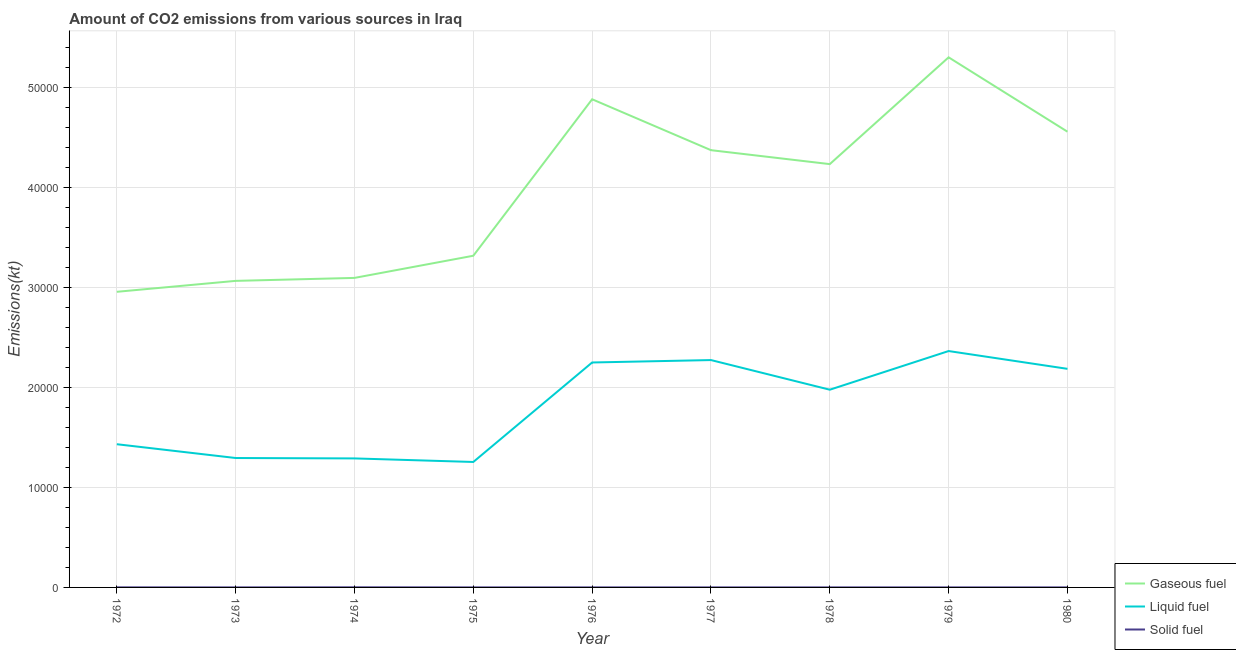What is the amount of co2 emissions from liquid fuel in 1972?
Offer a terse response. 1.43e+04. Across all years, what is the maximum amount of co2 emissions from solid fuel?
Make the answer very short. 11. Across all years, what is the minimum amount of co2 emissions from liquid fuel?
Make the answer very short. 1.25e+04. In which year was the amount of co2 emissions from gaseous fuel maximum?
Offer a terse response. 1979. What is the total amount of co2 emissions from solid fuel in the graph?
Provide a succinct answer. 44. What is the difference between the amount of co2 emissions from liquid fuel in 1973 and that in 1979?
Ensure brevity in your answer.  -1.07e+04. What is the difference between the amount of co2 emissions from gaseous fuel in 1975 and the amount of co2 emissions from solid fuel in 1972?
Offer a terse response. 3.31e+04. What is the average amount of co2 emissions from liquid fuel per year?
Offer a very short reply. 1.81e+04. In the year 1973, what is the difference between the amount of co2 emissions from gaseous fuel and amount of co2 emissions from solid fuel?
Provide a succinct answer. 3.06e+04. What is the ratio of the amount of co2 emissions from solid fuel in 1975 to that in 1980?
Your answer should be compact. 1. What is the difference between the highest and the second highest amount of co2 emissions from solid fuel?
Your answer should be very brief. 3.67. What is the difference between the highest and the lowest amount of co2 emissions from solid fuel?
Give a very brief answer. 7.33. In how many years, is the amount of co2 emissions from liquid fuel greater than the average amount of co2 emissions from liquid fuel taken over all years?
Provide a short and direct response. 5. Is it the case that in every year, the sum of the amount of co2 emissions from gaseous fuel and amount of co2 emissions from liquid fuel is greater than the amount of co2 emissions from solid fuel?
Your response must be concise. Yes. Is the amount of co2 emissions from gaseous fuel strictly greater than the amount of co2 emissions from liquid fuel over the years?
Your response must be concise. Yes. How many lines are there?
Ensure brevity in your answer.  3. How many years are there in the graph?
Provide a succinct answer. 9. Does the graph contain grids?
Provide a short and direct response. Yes. How are the legend labels stacked?
Keep it short and to the point. Vertical. What is the title of the graph?
Your answer should be compact. Amount of CO2 emissions from various sources in Iraq. What is the label or title of the Y-axis?
Keep it short and to the point. Emissions(kt). What is the Emissions(kt) of Gaseous fuel in 1972?
Give a very brief answer. 2.96e+04. What is the Emissions(kt) of Liquid fuel in 1972?
Provide a short and direct response. 1.43e+04. What is the Emissions(kt) in Solid fuel in 1972?
Provide a succinct answer. 7.33. What is the Emissions(kt) of Gaseous fuel in 1973?
Provide a succinct answer. 3.06e+04. What is the Emissions(kt) in Liquid fuel in 1973?
Keep it short and to the point. 1.29e+04. What is the Emissions(kt) in Solid fuel in 1973?
Your answer should be compact. 3.67. What is the Emissions(kt) in Gaseous fuel in 1974?
Provide a short and direct response. 3.09e+04. What is the Emissions(kt) of Liquid fuel in 1974?
Your response must be concise. 1.29e+04. What is the Emissions(kt) of Solid fuel in 1974?
Offer a very short reply. 11. What is the Emissions(kt) in Gaseous fuel in 1975?
Provide a short and direct response. 3.32e+04. What is the Emissions(kt) in Liquid fuel in 1975?
Offer a very short reply. 1.25e+04. What is the Emissions(kt) of Solid fuel in 1975?
Provide a short and direct response. 3.67. What is the Emissions(kt) in Gaseous fuel in 1976?
Provide a succinct answer. 4.88e+04. What is the Emissions(kt) of Liquid fuel in 1976?
Provide a succinct answer. 2.25e+04. What is the Emissions(kt) in Solid fuel in 1976?
Keep it short and to the point. 3.67. What is the Emissions(kt) of Gaseous fuel in 1977?
Ensure brevity in your answer.  4.37e+04. What is the Emissions(kt) of Liquid fuel in 1977?
Make the answer very short. 2.27e+04. What is the Emissions(kt) in Solid fuel in 1977?
Offer a very short reply. 3.67. What is the Emissions(kt) of Gaseous fuel in 1978?
Your answer should be compact. 4.23e+04. What is the Emissions(kt) of Liquid fuel in 1978?
Ensure brevity in your answer.  1.98e+04. What is the Emissions(kt) of Solid fuel in 1978?
Provide a short and direct response. 3.67. What is the Emissions(kt) in Gaseous fuel in 1979?
Offer a terse response. 5.30e+04. What is the Emissions(kt) of Liquid fuel in 1979?
Offer a very short reply. 2.36e+04. What is the Emissions(kt) of Solid fuel in 1979?
Make the answer very short. 3.67. What is the Emissions(kt) of Gaseous fuel in 1980?
Your answer should be very brief. 4.56e+04. What is the Emissions(kt) of Liquid fuel in 1980?
Offer a terse response. 2.19e+04. What is the Emissions(kt) of Solid fuel in 1980?
Your answer should be compact. 3.67. Across all years, what is the maximum Emissions(kt) in Gaseous fuel?
Offer a terse response. 5.30e+04. Across all years, what is the maximum Emissions(kt) of Liquid fuel?
Keep it short and to the point. 2.36e+04. Across all years, what is the maximum Emissions(kt) in Solid fuel?
Provide a succinct answer. 11. Across all years, what is the minimum Emissions(kt) of Gaseous fuel?
Offer a terse response. 2.96e+04. Across all years, what is the minimum Emissions(kt) of Liquid fuel?
Your answer should be very brief. 1.25e+04. Across all years, what is the minimum Emissions(kt) in Solid fuel?
Ensure brevity in your answer.  3.67. What is the total Emissions(kt) in Gaseous fuel in the graph?
Your answer should be very brief. 3.58e+05. What is the total Emissions(kt) of Liquid fuel in the graph?
Your response must be concise. 1.63e+05. What is the total Emissions(kt) in Solid fuel in the graph?
Give a very brief answer. 44. What is the difference between the Emissions(kt) of Gaseous fuel in 1972 and that in 1973?
Your answer should be very brief. -1092.77. What is the difference between the Emissions(kt) in Liquid fuel in 1972 and that in 1973?
Your answer should be very brief. 1378.79. What is the difference between the Emissions(kt) in Solid fuel in 1972 and that in 1973?
Your response must be concise. 3.67. What is the difference between the Emissions(kt) of Gaseous fuel in 1972 and that in 1974?
Offer a very short reply. -1389.79. What is the difference between the Emissions(kt) of Liquid fuel in 1972 and that in 1974?
Your response must be concise. 1419.13. What is the difference between the Emissions(kt) of Solid fuel in 1972 and that in 1974?
Your answer should be compact. -3.67. What is the difference between the Emissions(kt) in Gaseous fuel in 1972 and that in 1975?
Ensure brevity in your answer.  -3604.66. What is the difference between the Emissions(kt) in Liquid fuel in 1972 and that in 1975?
Keep it short and to the point. 1774.83. What is the difference between the Emissions(kt) of Solid fuel in 1972 and that in 1975?
Your answer should be compact. 3.67. What is the difference between the Emissions(kt) of Gaseous fuel in 1972 and that in 1976?
Ensure brevity in your answer.  -1.92e+04. What is the difference between the Emissions(kt) in Liquid fuel in 1972 and that in 1976?
Your response must be concise. -8170.08. What is the difference between the Emissions(kt) in Solid fuel in 1972 and that in 1976?
Your answer should be very brief. 3.67. What is the difference between the Emissions(kt) of Gaseous fuel in 1972 and that in 1977?
Give a very brief answer. -1.42e+04. What is the difference between the Emissions(kt) of Liquid fuel in 1972 and that in 1977?
Provide a succinct answer. -8412.1. What is the difference between the Emissions(kt) in Solid fuel in 1972 and that in 1977?
Make the answer very short. 3.67. What is the difference between the Emissions(kt) of Gaseous fuel in 1972 and that in 1978?
Keep it short and to the point. -1.28e+04. What is the difference between the Emissions(kt) in Liquid fuel in 1972 and that in 1978?
Provide a short and direct response. -5449.16. What is the difference between the Emissions(kt) in Solid fuel in 1972 and that in 1978?
Ensure brevity in your answer.  3.67. What is the difference between the Emissions(kt) in Gaseous fuel in 1972 and that in 1979?
Your answer should be compact. -2.34e+04. What is the difference between the Emissions(kt) in Liquid fuel in 1972 and that in 1979?
Provide a succinct answer. -9314.18. What is the difference between the Emissions(kt) in Solid fuel in 1972 and that in 1979?
Keep it short and to the point. 3.67. What is the difference between the Emissions(kt) of Gaseous fuel in 1972 and that in 1980?
Provide a short and direct response. -1.60e+04. What is the difference between the Emissions(kt) in Liquid fuel in 1972 and that in 1980?
Keep it short and to the point. -7535.69. What is the difference between the Emissions(kt) in Solid fuel in 1972 and that in 1980?
Provide a succinct answer. 3.67. What is the difference between the Emissions(kt) of Gaseous fuel in 1973 and that in 1974?
Keep it short and to the point. -297.03. What is the difference between the Emissions(kt) in Liquid fuel in 1973 and that in 1974?
Your answer should be compact. 40.34. What is the difference between the Emissions(kt) of Solid fuel in 1973 and that in 1974?
Your answer should be compact. -7.33. What is the difference between the Emissions(kt) in Gaseous fuel in 1973 and that in 1975?
Your answer should be very brief. -2511.89. What is the difference between the Emissions(kt) in Liquid fuel in 1973 and that in 1975?
Offer a very short reply. 396.04. What is the difference between the Emissions(kt) in Solid fuel in 1973 and that in 1975?
Make the answer very short. 0. What is the difference between the Emissions(kt) in Gaseous fuel in 1973 and that in 1976?
Provide a succinct answer. -1.82e+04. What is the difference between the Emissions(kt) in Liquid fuel in 1973 and that in 1976?
Provide a succinct answer. -9548.87. What is the difference between the Emissions(kt) in Solid fuel in 1973 and that in 1976?
Ensure brevity in your answer.  0. What is the difference between the Emissions(kt) in Gaseous fuel in 1973 and that in 1977?
Offer a terse response. -1.31e+04. What is the difference between the Emissions(kt) in Liquid fuel in 1973 and that in 1977?
Offer a terse response. -9790.89. What is the difference between the Emissions(kt) in Solid fuel in 1973 and that in 1977?
Your answer should be very brief. 0. What is the difference between the Emissions(kt) of Gaseous fuel in 1973 and that in 1978?
Offer a terse response. -1.17e+04. What is the difference between the Emissions(kt) in Liquid fuel in 1973 and that in 1978?
Provide a succinct answer. -6827.95. What is the difference between the Emissions(kt) in Solid fuel in 1973 and that in 1978?
Your answer should be compact. 0. What is the difference between the Emissions(kt) of Gaseous fuel in 1973 and that in 1979?
Keep it short and to the point. -2.23e+04. What is the difference between the Emissions(kt) of Liquid fuel in 1973 and that in 1979?
Make the answer very short. -1.07e+04. What is the difference between the Emissions(kt) in Gaseous fuel in 1973 and that in 1980?
Offer a very short reply. -1.49e+04. What is the difference between the Emissions(kt) of Liquid fuel in 1973 and that in 1980?
Your answer should be compact. -8914.48. What is the difference between the Emissions(kt) in Gaseous fuel in 1974 and that in 1975?
Keep it short and to the point. -2214.87. What is the difference between the Emissions(kt) in Liquid fuel in 1974 and that in 1975?
Your answer should be very brief. 355.7. What is the difference between the Emissions(kt) in Solid fuel in 1974 and that in 1975?
Make the answer very short. 7.33. What is the difference between the Emissions(kt) of Gaseous fuel in 1974 and that in 1976?
Keep it short and to the point. -1.79e+04. What is the difference between the Emissions(kt) of Liquid fuel in 1974 and that in 1976?
Keep it short and to the point. -9589.2. What is the difference between the Emissions(kt) in Solid fuel in 1974 and that in 1976?
Your answer should be very brief. 7.33. What is the difference between the Emissions(kt) of Gaseous fuel in 1974 and that in 1977?
Keep it short and to the point. -1.28e+04. What is the difference between the Emissions(kt) in Liquid fuel in 1974 and that in 1977?
Ensure brevity in your answer.  -9831.23. What is the difference between the Emissions(kt) in Solid fuel in 1974 and that in 1977?
Keep it short and to the point. 7.33. What is the difference between the Emissions(kt) in Gaseous fuel in 1974 and that in 1978?
Keep it short and to the point. -1.14e+04. What is the difference between the Emissions(kt) of Liquid fuel in 1974 and that in 1978?
Your answer should be compact. -6868.29. What is the difference between the Emissions(kt) in Solid fuel in 1974 and that in 1978?
Offer a very short reply. 7.33. What is the difference between the Emissions(kt) of Gaseous fuel in 1974 and that in 1979?
Offer a very short reply. -2.20e+04. What is the difference between the Emissions(kt) of Liquid fuel in 1974 and that in 1979?
Make the answer very short. -1.07e+04. What is the difference between the Emissions(kt) in Solid fuel in 1974 and that in 1979?
Make the answer very short. 7.33. What is the difference between the Emissions(kt) in Gaseous fuel in 1974 and that in 1980?
Your answer should be very brief. -1.46e+04. What is the difference between the Emissions(kt) in Liquid fuel in 1974 and that in 1980?
Give a very brief answer. -8954.81. What is the difference between the Emissions(kt) in Solid fuel in 1974 and that in 1980?
Keep it short and to the point. 7.33. What is the difference between the Emissions(kt) of Gaseous fuel in 1975 and that in 1976?
Your answer should be very brief. -1.56e+04. What is the difference between the Emissions(kt) of Liquid fuel in 1975 and that in 1976?
Provide a succinct answer. -9944.9. What is the difference between the Emissions(kt) in Solid fuel in 1975 and that in 1976?
Your response must be concise. 0. What is the difference between the Emissions(kt) in Gaseous fuel in 1975 and that in 1977?
Ensure brevity in your answer.  -1.06e+04. What is the difference between the Emissions(kt) in Liquid fuel in 1975 and that in 1977?
Provide a succinct answer. -1.02e+04. What is the difference between the Emissions(kt) of Solid fuel in 1975 and that in 1977?
Provide a short and direct response. 0. What is the difference between the Emissions(kt) in Gaseous fuel in 1975 and that in 1978?
Provide a succinct answer. -9160.17. What is the difference between the Emissions(kt) of Liquid fuel in 1975 and that in 1978?
Provide a short and direct response. -7223.99. What is the difference between the Emissions(kt) in Gaseous fuel in 1975 and that in 1979?
Your answer should be compact. -1.98e+04. What is the difference between the Emissions(kt) in Liquid fuel in 1975 and that in 1979?
Make the answer very short. -1.11e+04. What is the difference between the Emissions(kt) in Solid fuel in 1975 and that in 1979?
Provide a succinct answer. 0. What is the difference between the Emissions(kt) of Gaseous fuel in 1975 and that in 1980?
Keep it short and to the point. -1.24e+04. What is the difference between the Emissions(kt) of Liquid fuel in 1975 and that in 1980?
Give a very brief answer. -9310.51. What is the difference between the Emissions(kt) in Gaseous fuel in 1976 and that in 1977?
Offer a very short reply. 5089.8. What is the difference between the Emissions(kt) in Liquid fuel in 1976 and that in 1977?
Your answer should be very brief. -242.02. What is the difference between the Emissions(kt) in Solid fuel in 1976 and that in 1977?
Your answer should be very brief. 0. What is the difference between the Emissions(kt) in Gaseous fuel in 1976 and that in 1978?
Your response must be concise. 6483.26. What is the difference between the Emissions(kt) in Liquid fuel in 1976 and that in 1978?
Keep it short and to the point. 2720.91. What is the difference between the Emissions(kt) in Solid fuel in 1976 and that in 1978?
Provide a short and direct response. 0. What is the difference between the Emissions(kt) of Gaseous fuel in 1976 and that in 1979?
Your answer should be very brief. -4191.38. What is the difference between the Emissions(kt) in Liquid fuel in 1976 and that in 1979?
Ensure brevity in your answer.  -1144.1. What is the difference between the Emissions(kt) in Gaseous fuel in 1976 and that in 1980?
Give a very brief answer. 3241.63. What is the difference between the Emissions(kt) of Liquid fuel in 1976 and that in 1980?
Make the answer very short. 634.39. What is the difference between the Emissions(kt) of Gaseous fuel in 1977 and that in 1978?
Ensure brevity in your answer.  1393.46. What is the difference between the Emissions(kt) of Liquid fuel in 1977 and that in 1978?
Make the answer very short. 2962.94. What is the difference between the Emissions(kt) of Solid fuel in 1977 and that in 1978?
Give a very brief answer. 0. What is the difference between the Emissions(kt) in Gaseous fuel in 1977 and that in 1979?
Offer a terse response. -9281.18. What is the difference between the Emissions(kt) of Liquid fuel in 1977 and that in 1979?
Keep it short and to the point. -902.08. What is the difference between the Emissions(kt) in Solid fuel in 1977 and that in 1979?
Your answer should be very brief. 0. What is the difference between the Emissions(kt) in Gaseous fuel in 1977 and that in 1980?
Your answer should be very brief. -1848.17. What is the difference between the Emissions(kt) of Liquid fuel in 1977 and that in 1980?
Your answer should be compact. 876.41. What is the difference between the Emissions(kt) in Gaseous fuel in 1978 and that in 1979?
Provide a succinct answer. -1.07e+04. What is the difference between the Emissions(kt) of Liquid fuel in 1978 and that in 1979?
Your answer should be compact. -3865.02. What is the difference between the Emissions(kt) of Solid fuel in 1978 and that in 1979?
Offer a very short reply. 0. What is the difference between the Emissions(kt) in Gaseous fuel in 1978 and that in 1980?
Provide a succinct answer. -3241.63. What is the difference between the Emissions(kt) in Liquid fuel in 1978 and that in 1980?
Offer a terse response. -2086.52. What is the difference between the Emissions(kt) in Solid fuel in 1978 and that in 1980?
Offer a terse response. 0. What is the difference between the Emissions(kt) of Gaseous fuel in 1979 and that in 1980?
Ensure brevity in your answer.  7433.01. What is the difference between the Emissions(kt) in Liquid fuel in 1979 and that in 1980?
Your answer should be very brief. 1778.49. What is the difference between the Emissions(kt) in Gaseous fuel in 1972 and the Emissions(kt) in Liquid fuel in 1973?
Provide a succinct answer. 1.66e+04. What is the difference between the Emissions(kt) of Gaseous fuel in 1972 and the Emissions(kt) of Solid fuel in 1973?
Offer a very short reply. 2.95e+04. What is the difference between the Emissions(kt) in Liquid fuel in 1972 and the Emissions(kt) in Solid fuel in 1973?
Provide a short and direct response. 1.43e+04. What is the difference between the Emissions(kt) in Gaseous fuel in 1972 and the Emissions(kt) in Liquid fuel in 1974?
Provide a succinct answer. 1.67e+04. What is the difference between the Emissions(kt) of Gaseous fuel in 1972 and the Emissions(kt) of Solid fuel in 1974?
Make the answer very short. 2.95e+04. What is the difference between the Emissions(kt) in Liquid fuel in 1972 and the Emissions(kt) in Solid fuel in 1974?
Ensure brevity in your answer.  1.43e+04. What is the difference between the Emissions(kt) in Gaseous fuel in 1972 and the Emissions(kt) in Liquid fuel in 1975?
Your answer should be compact. 1.70e+04. What is the difference between the Emissions(kt) in Gaseous fuel in 1972 and the Emissions(kt) in Solid fuel in 1975?
Give a very brief answer. 2.95e+04. What is the difference between the Emissions(kt) in Liquid fuel in 1972 and the Emissions(kt) in Solid fuel in 1975?
Keep it short and to the point. 1.43e+04. What is the difference between the Emissions(kt) of Gaseous fuel in 1972 and the Emissions(kt) of Liquid fuel in 1976?
Offer a very short reply. 7066.31. What is the difference between the Emissions(kt) in Gaseous fuel in 1972 and the Emissions(kt) in Solid fuel in 1976?
Provide a short and direct response. 2.95e+04. What is the difference between the Emissions(kt) in Liquid fuel in 1972 and the Emissions(kt) in Solid fuel in 1976?
Provide a short and direct response. 1.43e+04. What is the difference between the Emissions(kt) in Gaseous fuel in 1972 and the Emissions(kt) in Liquid fuel in 1977?
Provide a short and direct response. 6824.29. What is the difference between the Emissions(kt) of Gaseous fuel in 1972 and the Emissions(kt) of Solid fuel in 1977?
Offer a very short reply. 2.95e+04. What is the difference between the Emissions(kt) in Liquid fuel in 1972 and the Emissions(kt) in Solid fuel in 1977?
Ensure brevity in your answer.  1.43e+04. What is the difference between the Emissions(kt) in Gaseous fuel in 1972 and the Emissions(kt) in Liquid fuel in 1978?
Make the answer very short. 9787.22. What is the difference between the Emissions(kt) in Gaseous fuel in 1972 and the Emissions(kt) in Solid fuel in 1978?
Your response must be concise. 2.95e+04. What is the difference between the Emissions(kt) of Liquid fuel in 1972 and the Emissions(kt) of Solid fuel in 1978?
Ensure brevity in your answer.  1.43e+04. What is the difference between the Emissions(kt) of Gaseous fuel in 1972 and the Emissions(kt) of Liquid fuel in 1979?
Keep it short and to the point. 5922.2. What is the difference between the Emissions(kt) of Gaseous fuel in 1972 and the Emissions(kt) of Solid fuel in 1979?
Provide a short and direct response. 2.95e+04. What is the difference between the Emissions(kt) of Liquid fuel in 1972 and the Emissions(kt) of Solid fuel in 1979?
Your answer should be compact. 1.43e+04. What is the difference between the Emissions(kt) in Gaseous fuel in 1972 and the Emissions(kt) in Liquid fuel in 1980?
Provide a short and direct response. 7700.7. What is the difference between the Emissions(kt) of Gaseous fuel in 1972 and the Emissions(kt) of Solid fuel in 1980?
Your response must be concise. 2.95e+04. What is the difference between the Emissions(kt) in Liquid fuel in 1972 and the Emissions(kt) in Solid fuel in 1980?
Provide a succinct answer. 1.43e+04. What is the difference between the Emissions(kt) of Gaseous fuel in 1973 and the Emissions(kt) of Liquid fuel in 1974?
Give a very brief answer. 1.77e+04. What is the difference between the Emissions(kt) of Gaseous fuel in 1973 and the Emissions(kt) of Solid fuel in 1974?
Keep it short and to the point. 3.06e+04. What is the difference between the Emissions(kt) of Liquid fuel in 1973 and the Emissions(kt) of Solid fuel in 1974?
Provide a short and direct response. 1.29e+04. What is the difference between the Emissions(kt) in Gaseous fuel in 1973 and the Emissions(kt) in Liquid fuel in 1975?
Keep it short and to the point. 1.81e+04. What is the difference between the Emissions(kt) of Gaseous fuel in 1973 and the Emissions(kt) of Solid fuel in 1975?
Your response must be concise. 3.06e+04. What is the difference between the Emissions(kt) of Liquid fuel in 1973 and the Emissions(kt) of Solid fuel in 1975?
Provide a short and direct response. 1.29e+04. What is the difference between the Emissions(kt) in Gaseous fuel in 1973 and the Emissions(kt) in Liquid fuel in 1976?
Ensure brevity in your answer.  8159.07. What is the difference between the Emissions(kt) of Gaseous fuel in 1973 and the Emissions(kt) of Solid fuel in 1976?
Offer a terse response. 3.06e+04. What is the difference between the Emissions(kt) in Liquid fuel in 1973 and the Emissions(kt) in Solid fuel in 1976?
Provide a succinct answer. 1.29e+04. What is the difference between the Emissions(kt) in Gaseous fuel in 1973 and the Emissions(kt) in Liquid fuel in 1977?
Your answer should be very brief. 7917.05. What is the difference between the Emissions(kt) of Gaseous fuel in 1973 and the Emissions(kt) of Solid fuel in 1977?
Ensure brevity in your answer.  3.06e+04. What is the difference between the Emissions(kt) of Liquid fuel in 1973 and the Emissions(kt) of Solid fuel in 1977?
Your answer should be compact. 1.29e+04. What is the difference between the Emissions(kt) of Gaseous fuel in 1973 and the Emissions(kt) of Liquid fuel in 1978?
Provide a short and direct response. 1.09e+04. What is the difference between the Emissions(kt) in Gaseous fuel in 1973 and the Emissions(kt) in Solid fuel in 1978?
Offer a terse response. 3.06e+04. What is the difference between the Emissions(kt) of Liquid fuel in 1973 and the Emissions(kt) of Solid fuel in 1978?
Offer a very short reply. 1.29e+04. What is the difference between the Emissions(kt) of Gaseous fuel in 1973 and the Emissions(kt) of Liquid fuel in 1979?
Provide a succinct answer. 7014.97. What is the difference between the Emissions(kt) in Gaseous fuel in 1973 and the Emissions(kt) in Solid fuel in 1979?
Your response must be concise. 3.06e+04. What is the difference between the Emissions(kt) in Liquid fuel in 1973 and the Emissions(kt) in Solid fuel in 1979?
Your response must be concise. 1.29e+04. What is the difference between the Emissions(kt) in Gaseous fuel in 1973 and the Emissions(kt) in Liquid fuel in 1980?
Make the answer very short. 8793.47. What is the difference between the Emissions(kt) in Gaseous fuel in 1973 and the Emissions(kt) in Solid fuel in 1980?
Keep it short and to the point. 3.06e+04. What is the difference between the Emissions(kt) of Liquid fuel in 1973 and the Emissions(kt) of Solid fuel in 1980?
Ensure brevity in your answer.  1.29e+04. What is the difference between the Emissions(kt) in Gaseous fuel in 1974 and the Emissions(kt) in Liquid fuel in 1975?
Keep it short and to the point. 1.84e+04. What is the difference between the Emissions(kt) in Gaseous fuel in 1974 and the Emissions(kt) in Solid fuel in 1975?
Your answer should be very brief. 3.09e+04. What is the difference between the Emissions(kt) of Liquid fuel in 1974 and the Emissions(kt) of Solid fuel in 1975?
Ensure brevity in your answer.  1.29e+04. What is the difference between the Emissions(kt) of Gaseous fuel in 1974 and the Emissions(kt) of Liquid fuel in 1976?
Ensure brevity in your answer.  8456.1. What is the difference between the Emissions(kt) in Gaseous fuel in 1974 and the Emissions(kt) in Solid fuel in 1976?
Make the answer very short. 3.09e+04. What is the difference between the Emissions(kt) of Liquid fuel in 1974 and the Emissions(kt) of Solid fuel in 1976?
Offer a terse response. 1.29e+04. What is the difference between the Emissions(kt) in Gaseous fuel in 1974 and the Emissions(kt) in Liquid fuel in 1977?
Make the answer very short. 8214.08. What is the difference between the Emissions(kt) in Gaseous fuel in 1974 and the Emissions(kt) in Solid fuel in 1977?
Keep it short and to the point. 3.09e+04. What is the difference between the Emissions(kt) of Liquid fuel in 1974 and the Emissions(kt) of Solid fuel in 1977?
Provide a succinct answer. 1.29e+04. What is the difference between the Emissions(kt) in Gaseous fuel in 1974 and the Emissions(kt) in Liquid fuel in 1978?
Ensure brevity in your answer.  1.12e+04. What is the difference between the Emissions(kt) in Gaseous fuel in 1974 and the Emissions(kt) in Solid fuel in 1978?
Your response must be concise. 3.09e+04. What is the difference between the Emissions(kt) of Liquid fuel in 1974 and the Emissions(kt) of Solid fuel in 1978?
Ensure brevity in your answer.  1.29e+04. What is the difference between the Emissions(kt) of Gaseous fuel in 1974 and the Emissions(kt) of Liquid fuel in 1979?
Your response must be concise. 7312. What is the difference between the Emissions(kt) of Gaseous fuel in 1974 and the Emissions(kt) of Solid fuel in 1979?
Ensure brevity in your answer.  3.09e+04. What is the difference between the Emissions(kt) of Liquid fuel in 1974 and the Emissions(kt) of Solid fuel in 1979?
Provide a short and direct response. 1.29e+04. What is the difference between the Emissions(kt) in Gaseous fuel in 1974 and the Emissions(kt) in Liquid fuel in 1980?
Keep it short and to the point. 9090.49. What is the difference between the Emissions(kt) in Gaseous fuel in 1974 and the Emissions(kt) in Solid fuel in 1980?
Make the answer very short. 3.09e+04. What is the difference between the Emissions(kt) in Liquid fuel in 1974 and the Emissions(kt) in Solid fuel in 1980?
Give a very brief answer. 1.29e+04. What is the difference between the Emissions(kt) of Gaseous fuel in 1975 and the Emissions(kt) of Liquid fuel in 1976?
Keep it short and to the point. 1.07e+04. What is the difference between the Emissions(kt) in Gaseous fuel in 1975 and the Emissions(kt) in Solid fuel in 1976?
Provide a succinct answer. 3.32e+04. What is the difference between the Emissions(kt) in Liquid fuel in 1975 and the Emissions(kt) in Solid fuel in 1976?
Make the answer very short. 1.25e+04. What is the difference between the Emissions(kt) of Gaseous fuel in 1975 and the Emissions(kt) of Liquid fuel in 1977?
Give a very brief answer. 1.04e+04. What is the difference between the Emissions(kt) in Gaseous fuel in 1975 and the Emissions(kt) in Solid fuel in 1977?
Provide a short and direct response. 3.32e+04. What is the difference between the Emissions(kt) of Liquid fuel in 1975 and the Emissions(kt) of Solid fuel in 1977?
Your response must be concise. 1.25e+04. What is the difference between the Emissions(kt) in Gaseous fuel in 1975 and the Emissions(kt) in Liquid fuel in 1978?
Give a very brief answer. 1.34e+04. What is the difference between the Emissions(kt) in Gaseous fuel in 1975 and the Emissions(kt) in Solid fuel in 1978?
Your response must be concise. 3.32e+04. What is the difference between the Emissions(kt) in Liquid fuel in 1975 and the Emissions(kt) in Solid fuel in 1978?
Offer a terse response. 1.25e+04. What is the difference between the Emissions(kt) of Gaseous fuel in 1975 and the Emissions(kt) of Liquid fuel in 1979?
Your answer should be very brief. 9526.87. What is the difference between the Emissions(kt) in Gaseous fuel in 1975 and the Emissions(kt) in Solid fuel in 1979?
Make the answer very short. 3.32e+04. What is the difference between the Emissions(kt) in Liquid fuel in 1975 and the Emissions(kt) in Solid fuel in 1979?
Your answer should be compact. 1.25e+04. What is the difference between the Emissions(kt) of Gaseous fuel in 1975 and the Emissions(kt) of Liquid fuel in 1980?
Offer a very short reply. 1.13e+04. What is the difference between the Emissions(kt) in Gaseous fuel in 1975 and the Emissions(kt) in Solid fuel in 1980?
Give a very brief answer. 3.32e+04. What is the difference between the Emissions(kt) of Liquid fuel in 1975 and the Emissions(kt) of Solid fuel in 1980?
Give a very brief answer. 1.25e+04. What is the difference between the Emissions(kt) in Gaseous fuel in 1976 and the Emissions(kt) in Liquid fuel in 1977?
Offer a very short reply. 2.61e+04. What is the difference between the Emissions(kt) of Gaseous fuel in 1976 and the Emissions(kt) of Solid fuel in 1977?
Offer a terse response. 4.88e+04. What is the difference between the Emissions(kt) in Liquid fuel in 1976 and the Emissions(kt) in Solid fuel in 1977?
Make the answer very short. 2.25e+04. What is the difference between the Emissions(kt) of Gaseous fuel in 1976 and the Emissions(kt) of Liquid fuel in 1978?
Offer a terse response. 2.90e+04. What is the difference between the Emissions(kt) in Gaseous fuel in 1976 and the Emissions(kt) in Solid fuel in 1978?
Offer a very short reply. 4.88e+04. What is the difference between the Emissions(kt) of Liquid fuel in 1976 and the Emissions(kt) of Solid fuel in 1978?
Your answer should be very brief. 2.25e+04. What is the difference between the Emissions(kt) in Gaseous fuel in 1976 and the Emissions(kt) in Liquid fuel in 1979?
Give a very brief answer. 2.52e+04. What is the difference between the Emissions(kt) in Gaseous fuel in 1976 and the Emissions(kt) in Solid fuel in 1979?
Keep it short and to the point. 4.88e+04. What is the difference between the Emissions(kt) of Liquid fuel in 1976 and the Emissions(kt) of Solid fuel in 1979?
Provide a short and direct response. 2.25e+04. What is the difference between the Emissions(kt) in Gaseous fuel in 1976 and the Emissions(kt) in Liquid fuel in 1980?
Keep it short and to the point. 2.69e+04. What is the difference between the Emissions(kt) in Gaseous fuel in 1976 and the Emissions(kt) in Solid fuel in 1980?
Make the answer very short. 4.88e+04. What is the difference between the Emissions(kt) of Liquid fuel in 1976 and the Emissions(kt) of Solid fuel in 1980?
Give a very brief answer. 2.25e+04. What is the difference between the Emissions(kt) of Gaseous fuel in 1977 and the Emissions(kt) of Liquid fuel in 1978?
Make the answer very short. 2.39e+04. What is the difference between the Emissions(kt) in Gaseous fuel in 1977 and the Emissions(kt) in Solid fuel in 1978?
Provide a short and direct response. 4.37e+04. What is the difference between the Emissions(kt) of Liquid fuel in 1977 and the Emissions(kt) of Solid fuel in 1978?
Provide a short and direct response. 2.27e+04. What is the difference between the Emissions(kt) of Gaseous fuel in 1977 and the Emissions(kt) of Liquid fuel in 1979?
Your answer should be compact. 2.01e+04. What is the difference between the Emissions(kt) in Gaseous fuel in 1977 and the Emissions(kt) in Solid fuel in 1979?
Provide a short and direct response. 4.37e+04. What is the difference between the Emissions(kt) in Liquid fuel in 1977 and the Emissions(kt) in Solid fuel in 1979?
Your answer should be compact. 2.27e+04. What is the difference between the Emissions(kt) of Gaseous fuel in 1977 and the Emissions(kt) of Liquid fuel in 1980?
Offer a terse response. 2.19e+04. What is the difference between the Emissions(kt) in Gaseous fuel in 1977 and the Emissions(kt) in Solid fuel in 1980?
Your response must be concise. 4.37e+04. What is the difference between the Emissions(kt) of Liquid fuel in 1977 and the Emissions(kt) of Solid fuel in 1980?
Your answer should be very brief. 2.27e+04. What is the difference between the Emissions(kt) of Gaseous fuel in 1978 and the Emissions(kt) of Liquid fuel in 1979?
Make the answer very short. 1.87e+04. What is the difference between the Emissions(kt) of Gaseous fuel in 1978 and the Emissions(kt) of Solid fuel in 1979?
Your answer should be compact. 4.23e+04. What is the difference between the Emissions(kt) in Liquid fuel in 1978 and the Emissions(kt) in Solid fuel in 1979?
Give a very brief answer. 1.98e+04. What is the difference between the Emissions(kt) in Gaseous fuel in 1978 and the Emissions(kt) in Liquid fuel in 1980?
Your answer should be compact. 2.05e+04. What is the difference between the Emissions(kt) in Gaseous fuel in 1978 and the Emissions(kt) in Solid fuel in 1980?
Ensure brevity in your answer.  4.23e+04. What is the difference between the Emissions(kt) of Liquid fuel in 1978 and the Emissions(kt) of Solid fuel in 1980?
Your response must be concise. 1.98e+04. What is the difference between the Emissions(kt) in Gaseous fuel in 1979 and the Emissions(kt) in Liquid fuel in 1980?
Your answer should be very brief. 3.11e+04. What is the difference between the Emissions(kt) in Gaseous fuel in 1979 and the Emissions(kt) in Solid fuel in 1980?
Give a very brief answer. 5.30e+04. What is the difference between the Emissions(kt) of Liquid fuel in 1979 and the Emissions(kt) of Solid fuel in 1980?
Make the answer very short. 2.36e+04. What is the average Emissions(kt) of Gaseous fuel per year?
Provide a succinct answer. 3.97e+04. What is the average Emissions(kt) of Liquid fuel per year?
Your answer should be very brief. 1.81e+04. What is the average Emissions(kt) of Solid fuel per year?
Keep it short and to the point. 4.89. In the year 1972, what is the difference between the Emissions(kt) of Gaseous fuel and Emissions(kt) of Liquid fuel?
Your answer should be very brief. 1.52e+04. In the year 1972, what is the difference between the Emissions(kt) of Gaseous fuel and Emissions(kt) of Solid fuel?
Keep it short and to the point. 2.95e+04. In the year 1972, what is the difference between the Emissions(kt) of Liquid fuel and Emissions(kt) of Solid fuel?
Provide a succinct answer. 1.43e+04. In the year 1973, what is the difference between the Emissions(kt) of Gaseous fuel and Emissions(kt) of Liquid fuel?
Offer a terse response. 1.77e+04. In the year 1973, what is the difference between the Emissions(kt) of Gaseous fuel and Emissions(kt) of Solid fuel?
Provide a short and direct response. 3.06e+04. In the year 1973, what is the difference between the Emissions(kt) of Liquid fuel and Emissions(kt) of Solid fuel?
Offer a terse response. 1.29e+04. In the year 1974, what is the difference between the Emissions(kt) of Gaseous fuel and Emissions(kt) of Liquid fuel?
Your response must be concise. 1.80e+04. In the year 1974, what is the difference between the Emissions(kt) in Gaseous fuel and Emissions(kt) in Solid fuel?
Your answer should be very brief. 3.09e+04. In the year 1974, what is the difference between the Emissions(kt) in Liquid fuel and Emissions(kt) in Solid fuel?
Ensure brevity in your answer.  1.29e+04. In the year 1975, what is the difference between the Emissions(kt) of Gaseous fuel and Emissions(kt) of Liquid fuel?
Provide a short and direct response. 2.06e+04. In the year 1975, what is the difference between the Emissions(kt) of Gaseous fuel and Emissions(kt) of Solid fuel?
Your answer should be compact. 3.32e+04. In the year 1975, what is the difference between the Emissions(kt) in Liquid fuel and Emissions(kt) in Solid fuel?
Give a very brief answer. 1.25e+04. In the year 1976, what is the difference between the Emissions(kt) in Gaseous fuel and Emissions(kt) in Liquid fuel?
Provide a succinct answer. 2.63e+04. In the year 1976, what is the difference between the Emissions(kt) of Gaseous fuel and Emissions(kt) of Solid fuel?
Your answer should be compact. 4.88e+04. In the year 1976, what is the difference between the Emissions(kt) of Liquid fuel and Emissions(kt) of Solid fuel?
Your response must be concise. 2.25e+04. In the year 1977, what is the difference between the Emissions(kt) in Gaseous fuel and Emissions(kt) in Liquid fuel?
Your answer should be very brief. 2.10e+04. In the year 1977, what is the difference between the Emissions(kt) in Gaseous fuel and Emissions(kt) in Solid fuel?
Give a very brief answer. 4.37e+04. In the year 1977, what is the difference between the Emissions(kt) of Liquid fuel and Emissions(kt) of Solid fuel?
Keep it short and to the point. 2.27e+04. In the year 1978, what is the difference between the Emissions(kt) of Gaseous fuel and Emissions(kt) of Liquid fuel?
Provide a succinct answer. 2.26e+04. In the year 1978, what is the difference between the Emissions(kt) in Gaseous fuel and Emissions(kt) in Solid fuel?
Provide a short and direct response. 4.23e+04. In the year 1978, what is the difference between the Emissions(kt) of Liquid fuel and Emissions(kt) of Solid fuel?
Your response must be concise. 1.98e+04. In the year 1979, what is the difference between the Emissions(kt) of Gaseous fuel and Emissions(kt) of Liquid fuel?
Your answer should be very brief. 2.94e+04. In the year 1979, what is the difference between the Emissions(kt) of Gaseous fuel and Emissions(kt) of Solid fuel?
Make the answer very short. 5.30e+04. In the year 1979, what is the difference between the Emissions(kt) in Liquid fuel and Emissions(kt) in Solid fuel?
Your response must be concise. 2.36e+04. In the year 1980, what is the difference between the Emissions(kt) in Gaseous fuel and Emissions(kt) in Liquid fuel?
Offer a very short reply. 2.37e+04. In the year 1980, what is the difference between the Emissions(kt) of Gaseous fuel and Emissions(kt) of Solid fuel?
Offer a terse response. 4.56e+04. In the year 1980, what is the difference between the Emissions(kt) in Liquid fuel and Emissions(kt) in Solid fuel?
Ensure brevity in your answer.  2.18e+04. What is the ratio of the Emissions(kt) of Gaseous fuel in 1972 to that in 1973?
Make the answer very short. 0.96. What is the ratio of the Emissions(kt) of Liquid fuel in 1972 to that in 1973?
Your answer should be compact. 1.11. What is the ratio of the Emissions(kt) in Gaseous fuel in 1972 to that in 1974?
Give a very brief answer. 0.96. What is the ratio of the Emissions(kt) of Liquid fuel in 1972 to that in 1974?
Provide a succinct answer. 1.11. What is the ratio of the Emissions(kt) of Solid fuel in 1972 to that in 1974?
Your answer should be compact. 0.67. What is the ratio of the Emissions(kt) in Gaseous fuel in 1972 to that in 1975?
Give a very brief answer. 0.89. What is the ratio of the Emissions(kt) in Liquid fuel in 1972 to that in 1975?
Your answer should be very brief. 1.14. What is the ratio of the Emissions(kt) of Solid fuel in 1972 to that in 1975?
Your response must be concise. 2. What is the ratio of the Emissions(kt) of Gaseous fuel in 1972 to that in 1976?
Ensure brevity in your answer.  0.61. What is the ratio of the Emissions(kt) in Liquid fuel in 1972 to that in 1976?
Provide a succinct answer. 0.64. What is the ratio of the Emissions(kt) of Gaseous fuel in 1972 to that in 1977?
Ensure brevity in your answer.  0.68. What is the ratio of the Emissions(kt) in Liquid fuel in 1972 to that in 1977?
Your response must be concise. 0.63. What is the ratio of the Emissions(kt) in Gaseous fuel in 1972 to that in 1978?
Your answer should be compact. 0.7. What is the ratio of the Emissions(kt) of Liquid fuel in 1972 to that in 1978?
Provide a succinct answer. 0.72. What is the ratio of the Emissions(kt) in Gaseous fuel in 1972 to that in 1979?
Offer a terse response. 0.56. What is the ratio of the Emissions(kt) in Liquid fuel in 1972 to that in 1979?
Give a very brief answer. 0.61. What is the ratio of the Emissions(kt) in Solid fuel in 1972 to that in 1979?
Provide a succinct answer. 2. What is the ratio of the Emissions(kt) in Gaseous fuel in 1972 to that in 1980?
Ensure brevity in your answer.  0.65. What is the ratio of the Emissions(kt) in Liquid fuel in 1972 to that in 1980?
Ensure brevity in your answer.  0.66. What is the ratio of the Emissions(kt) of Liquid fuel in 1973 to that in 1974?
Provide a short and direct response. 1. What is the ratio of the Emissions(kt) in Gaseous fuel in 1973 to that in 1975?
Keep it short and to the point. 0.92. What is the ratio of the Emissions(kt) of Liquid fuel in 1973 to that in 1975?
Make the answer very short. 1.03. What is the ratio of the Emissions(kt) of Solid fuel in 1973 to that in 1975?
Keep it short and to the point. 1. What is the ratio of the Emissions(kt) of Gaseous fuel in 1973 to that in 1976?
Offer a very short reply. 0.63. What is the ratio of the Emissions(kt) of Liquid fuel in 1973 to that in 1976?
Keep it short and to the point. 0.58. What is the ratio of the Emissions(kt) of Solid fuel in 1973 to that in 1976?
Your response must be concise. 1. What is the ratio of the Emissions(kt) of Gaseous fuel in 1973 to that in 1977?
Your response must be concise. 0.7. What is the ratio of the Emissions(kt) of Liquid fuel in 1973 to that in 1977?
Ensure brevity in your answer.  0.57. What is the ratio of the Emissions(kt) in Gaseous fuel in 1973 to that in 1978?
Offer a terse response. 0.72. What is the ratio of the Emissions(kt) in Liquid fuel in 1973 to that in 1978?
Provide a short and direct response. 0.65. What is the ratio of the Emissions(kt) in Solid fuel in 1973 to that in 1978?
Your answer should be very brief. 1. What is the ratio of the Emissions(kt) in Gaseous fuel in 1973 to that in 1979?
Your answer should be compact. 0.58. What is the ratio of the Emissions(kt) of Liquid fuel in 1973 to that in 1979?
Keep it short and to the point. 0.55. What is the ratio of the Emissions(kt) in Gaseous fuel in 1973 to that in 1980?
Your response must be concise. 0.67. What is the ratio of the Emissions(kt) in Liquid fuel in 1973 to that in 1980?
Your response must be concise. 0.59. What is the ratio of the Emissions(kt) in Solid fuel in 1973 to that in 1980?
Provide a short and direct response. 1. What is the ratio of the Emissions(kt) of Gaseous fuel in 1974 to that in 1975?
Give a very brief answer. 0.93. What is the ratio of the Emissions(kt) of Liquid fuel in 1974 to that in 1975?
Your answer should be very brief. 1.03. What is the ratio of the Emissions(kt) of Solid fuel in 1974 to that in 1975?
Give a very brief answer. 3. What is the ratio of the Emissions(kt) in Gaseous fuel in 1974 to that in 1976?
Provide a short and direct response. 0.63. What is the ratio of the Emissions(kt) in Liquid fuel in 1974 to that in 1976?
Offer a terse response. 0.57. What is the ratio of the Emissions(kt) in Gaseous fuel in 1974 to that in 1977?
Offer a very short reply. 0.71. What is the ratio of the Emissions(kt) in Liquid fuel in 1974 to that in 1977?
Provide a short and direct response. 0.57. What is the ratio of the Emissions(kt) of Gaseous fuel in 1974 to that in 1978?
Offer a terse response. 0.73. What is the ratio of the Emissions(kt) in Liquid fuel in 1974 to that in 1978?
Make the answer very short. 0.65. What is the ratio of the Emissions(kt) in Solid fuel in 1974 to that in 1978?
Make the answer very short. 3. What is the ratio of the Emissions(kt) of Gaseous fuel in 1974 to that in 1979?
Make the answer very short. 0.58. What is the ratio of the Emissions(kt) in Liquid fuel in 1974 to that in 1979?
Make the answer very short. 0.55. What is the ratio of the Emissions(kt) in Gaseous fuel in 1974 to that in 1980?
Your response must be concise. 0.68. What is the ratio of the Emissions(kt) in Liquid fuel in 1974 to that in 1980?
Keep it short and to the point. 0.59. What is the ratio of the Emissions(kt) of Gaseous fuel in 1975 to that in 1976?
Give a very brief answer. 0.68. What is the ratio of the Emissions(kt) in Liquid fuel in 1975 to that in 1976?
Ensure brevity in your answer.  0.56. What is the ratio of the Emissions(kt) in Solid fuel in 1975 to that in 1976?
Keep it short and to the point. 1. What is the ratio of the Emissions(kt) in Gaseous fuel in 1975 to that in 1977?
Keep it short and to the point. 0.76. What is the ratio of the Emissions(kt) in Liquid fuel in 1975 to that in 1977?
Make the answer very short. 0.55. What is the ratio of the Emissions(kt) in Gaseous fuel in 1975 to that in 1978?
Make the answer very short. 0.78. What is the ratio of the Emissions(kt) of Liquid fuel in 1975 to that in 1978?
Your answer should be very brief. 0.63. What is the ratio of the Emissions(kt) in Solid fuel in 1975 to that in 1978?
Offer a very short reply. 1. What is the ratio of the Emissions(kt) of Gaseous fuel in 1975 to that in 1979?
Provide a short and direct response. 0.63. What is the ratio of the Emissions(kt) of Liquid fuel in 1975 to that in 1979?
Offer a terse response. 0.53. What is the ratio of the Emissions(kt) in Solid fuel in 1975 to that in 1979?
Your response must be concise. 1. What is the ratio of the Emissions(kt) in Gaseous fuel in 1975 to that in 1980?
Provide a succinct answer. 0.73. What is the ratio of the Emissions(kt) of Liquid fuel in 1975 to that in 1980?
Provide a succinct answer. 0.57. What is the ratio of the Emissions(kt) in Solid fuel in 1975 to that in 1980?
Your answer should be very brief. 1. What is the ratio of the Emissions(kt) of Gaseous fuel in 1976 to that in 1977?
Your answer should be compact. 1.12. What is the ratio of the Emissions(kt) in Gaseous fuel in 1976 to that in 1978?
Make the answer very short. 1.15. What is the ratio of the Emissions(kt) of Liquid fuel in 1976 to that in 1978?
Keep it short and to the point. 1.14. What is the ratio of the Emissions(kt) in Solid fuel in 1976 to that in 1978?
Give a very brief answer. 1. What is the ratio of the Emissions(kt) in Gaseous fuel in 1976 to that in 1979?
Offer a terse response. 0.92. What is the ratio of the Emissions(kt) of Liquid fuel in 1976 to that in 1979?
Offer a terse response. 0.95. What is the ratio of the Emissions(kt) of Solid fuel in 1976 to that in 1979?
Provide a short and direct response. 1. What is the ratio of the Emissions(kt) in Gaseous fuel in 1976 to that in 1980?
Your answer should be compact. 1.07. What is the ratio of the Emissions(kt) in Liquid fuel in 1976 to that in 1980?
Give a very brief answer. 1.03. What is the ratio of the Emissions(kt) in Gaseous fuel in 1977 to that in 1978?
Provide a short and direct response. 1.03. What is the ratio of the Emissions(kt) of Liquid fuel in 1977 to that in 1978?
Provide a short and direct response. 1.15. What is the ratio of the Emissions(kt) in Solid fuel in 1977 to that in 1978?
Ensure brevity in your answer.  1. What is the ratio of the Emissions(kt) in Gaseous fuel in 1977 to that in 1979?
Your response must be concise. 0.82. What is the ratio of the Emissions(kt) in Liquid fuel in 1977 to that in 1979?
Keep it short and to the point. 0.96. What is the ratio of the Emissions(kt) of Solid fuel in 1977 to that in 1979?
Offer a terse response. 1. What is the ratio of the Emissions(kt) of Gaseous fuel in 1977 to that in 1980?
Provide a short and direct response. 0.96. What is the ratio of the Emissions(kt) of Liquid fuel in 1977 to that in 1980?
Offer a very short reply. 1.04. What is the ratio of the Emissions(kt) in Solid fuel in 1977 to that in 1980?
Your answer should be very brief. 1. What is the ratio of the Emissions(kt) of Gaseous fuel in 1978 to that in 1979?
Offer a terse response. 0.8. What is the ratio of the Emissions(kt) in Liquid fuel in 1978 to that in 1979?
Your answer should be very brief. 0.84. What is the ratio of the Emissions(kt) of Solid fuel in 1978 to that in 1979?
Provide a short and direct response. 1. What is the ratio of the Emissions(kt) of Gaseous fuel in 1978 to that in 1980?
Your response must be concise. 0.93. What is the ratio of the Emissions(kt) in Liquid fuel in 1978 to that in 1980?
Your answer should be compact. 0.9. What is the ratio of the Emissions(kt) in Gaseous fuel in 1979 to that in 1980?
Offer a terse response. 1.16. What is the ratio of the Emissions(kt) in Liquid fuel in 1979 to that in 1980?
Provide a succinct answer. 1.08. What is the ratio of the Emissions(kt) of Solid fuel in 1979 to that in 1980?
Offer a very short reply. 1. What is the difference between the highest and the second highest Emissions(kt) in Gaseous fuel?
Keep it short and to the point. 4191.38. What is the difference between the highest and the second highest Emissions(kt) in Liquid fuel?
Keep it short and to the point. 902.08. What is the difference between the highest and the second highest Emissions(kt) in Solid fuel?
Your answer should be very brief. 3.67. What is the difference between the highest and the lowest Emissions(kt) of Gaseous fuel?
Keep it short and to the point. 2.34e+04. What is the difference between the highest and the lowest Emissions(kt) in Liquid fuel?
Offer a terse response. 1.11e+04. What is the difference between the highest and the lowest Emissions(kt) of Solid fuel?
Give a very brief answer. 7.33. 